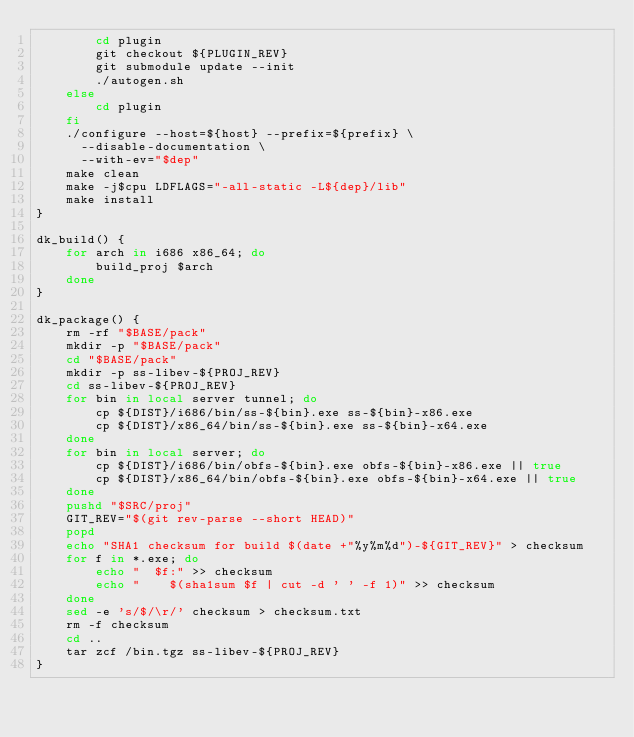<code> <loc_0><loc_0><loc_500><loc_500><_Bash_>        cd plugin
        git checkout ${PLUGIN_REV}
        git submodule update --init
        ./autogen.sh
    else
        cd plugin
    fi
    ./configure --host=${host} --prefix=${prefix} \
      --disable-documentation \
      --with-ev="$dep"
    make clean
    make -j$cpu LDFLAGS="-all-static -L${dep}/lib"
    make install
}

dk_build() {
    for arch in i686 x86_64; do
        build_proj $arch
    done
}

dk_package() {
    rm -rf "$BASE/pack"
    mkdir -p "$BASE/pack"
    cd "$BASE/pack"
    mkdir -p ss-libev-${PROJ_REV}
    cd ss-libev-${PROJ_REV}
    for bin in local server tunnel; do
        cp ${DIST}/i686/bin/ss-${bin}.exe ss-${bin}-x86.exe
        cp ${DIST}/x86_64/bin/ss-${bin}.exe ss-${bin}-x64.exe
    done
    for bin in local server; do
        cp ${DIST}/i686/bin/obfs-${bin}.exe obfs-${bin}-x86.exe || true
        cp ${DIST}/x86_64/bin/obfs-${bin}.exe obfs-${bin}-x64.exe || true
    done
    pushd "$SRC/proj"
    GIT_REV="$(git rev-parse --short HEAD)"
    popd
    echo "SHA1 checksum for build $(date +"%y%m%d")-${GIT_REV}" > checksum
    for f in *.exe; do
        echo "  $f:" >> checksum
        echo "    $(sha1sum $f | cut -d ' ' -f 1)" >> checksum
    done
    sed -e 's/$/\r/' checksum > checksum.txt
    rm -f checksum
    cd ..
    tar zcf /bin.tgz ss-libev-${PROJ_REV}
}
</code> 